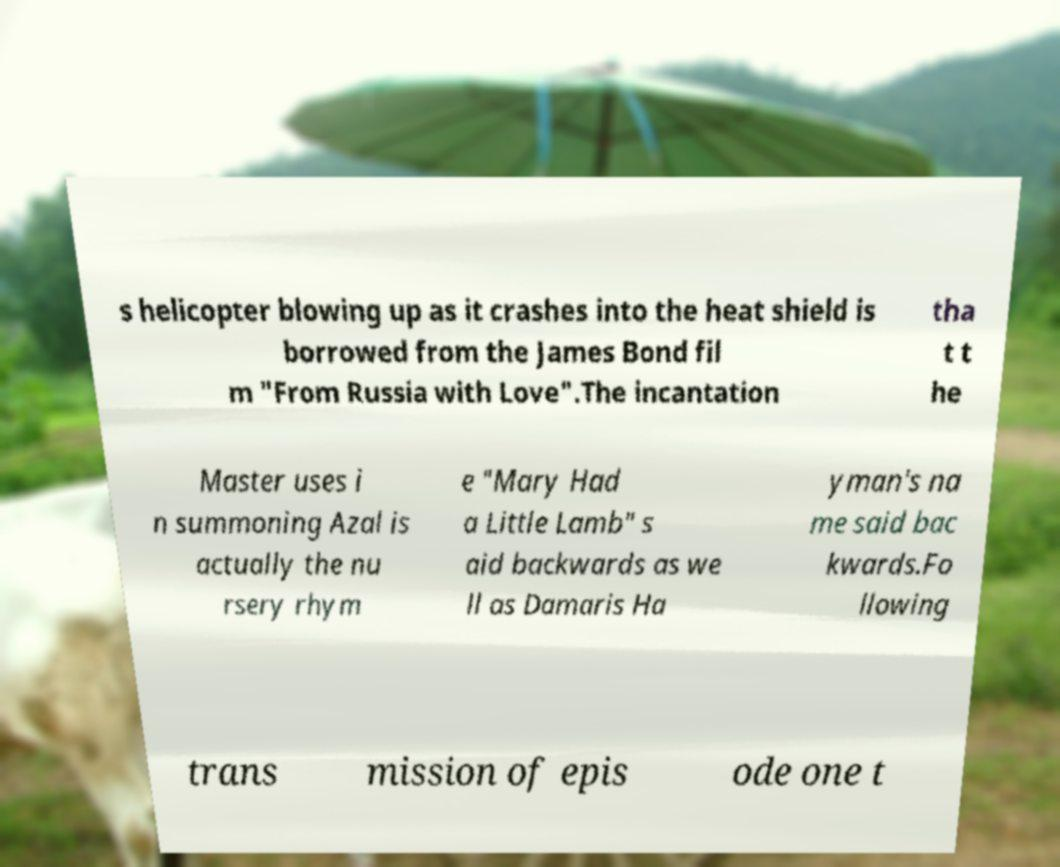What messages or text are displayed in this image? I need them in a readable, typed format. s helicopter blowing up as it crashes into the heat shield is borrowed from the James Bond fil m "From Russia with Love".The incantation tha t t he Master uses i n summoning Azal is actually the nu rsery rhym e "Mary Had a Little Lamb" s aid backwards as we ll as Damaris Ha yman's na me said bac kwards.Fo llowing trans mission of epis ode one t 